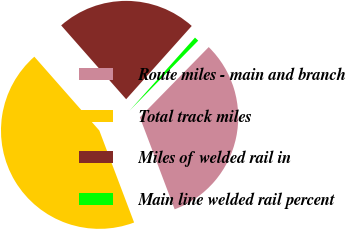Convert chart. <chart><loc_0><loc_0><loc_500><loc_500><pie_chart><fcel>Route miles - main and branch<fcel>Total track miles<fcel>Miles of welded rail in<fcel>Main line welded rail percent<nl><fcel>31.91%<fcel>44.27%<fcel>23.11%<fcel>0.72%<nl></chart> 